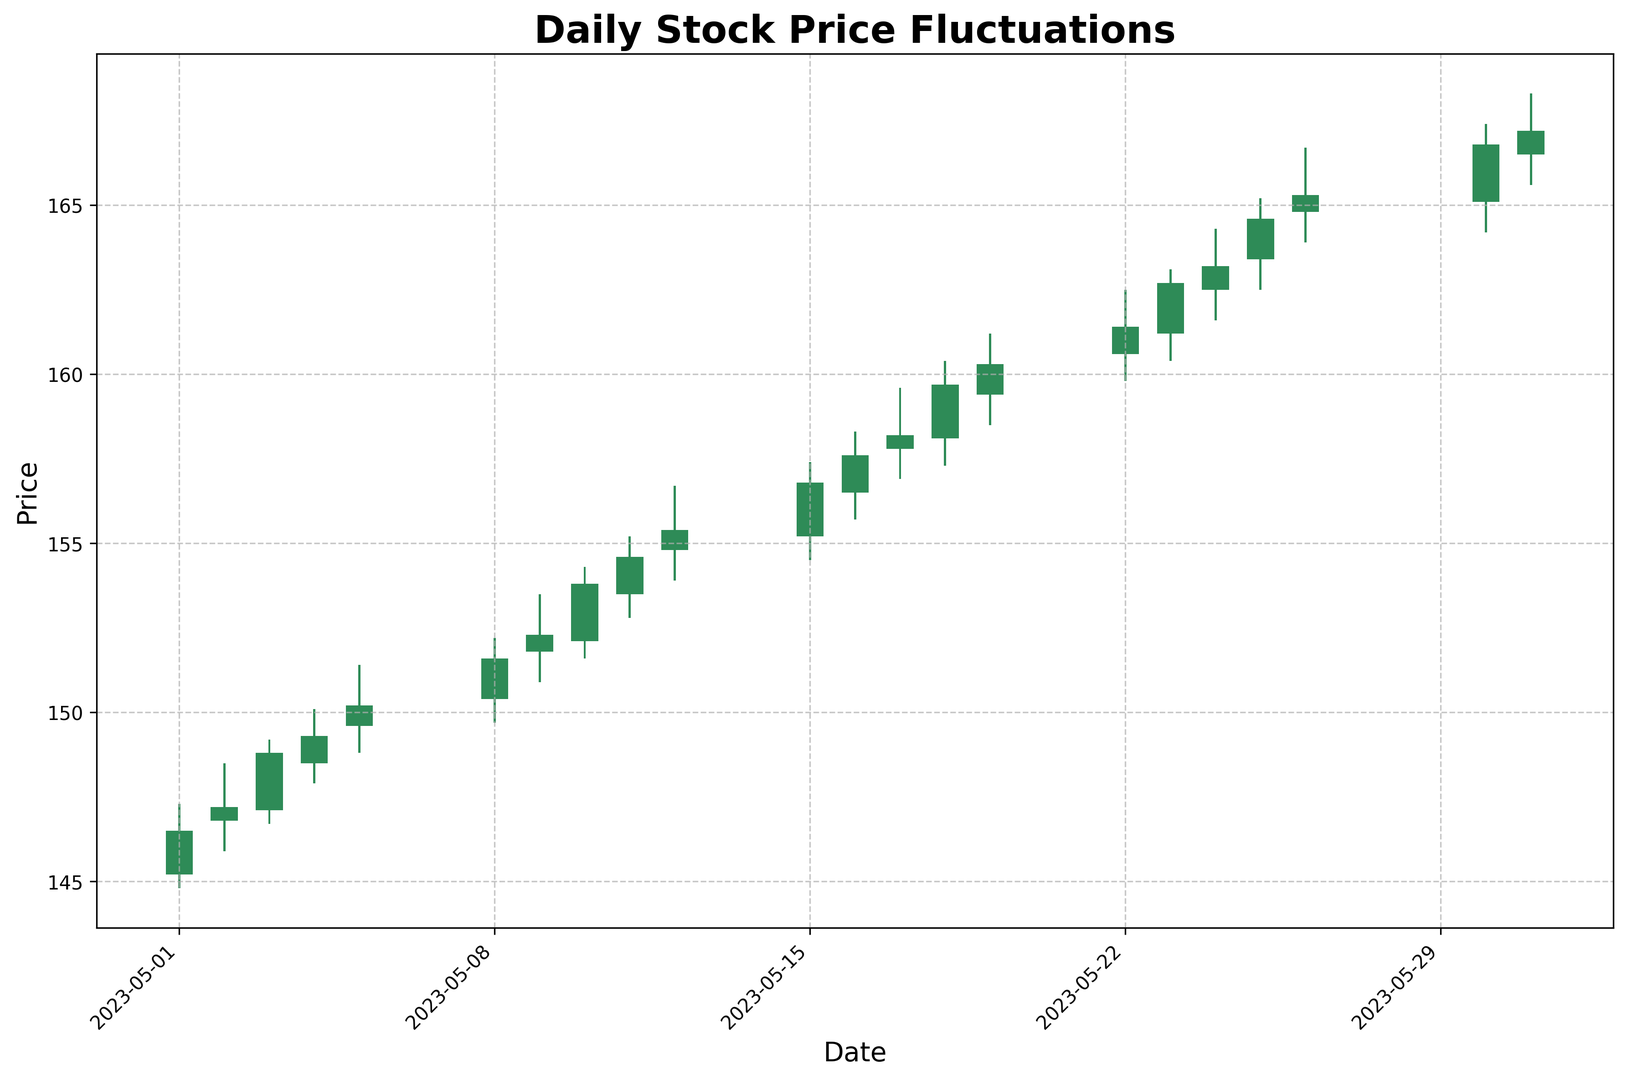Which day had the highest closing price? To determine the highest closing price, examine the closing price column for the peak value. The highest closing price is on 2023-05-31.
Answer: 2023-05-31 Which day had the largest difference between high and low prices? Calculate the difference between the high and low prices for each day and identify the maximum. The day with the largest difference is 2023-05-26, with a difference of 166.70 - 163.90 = 2.80.
Answer: 2023-05-26 Compare the opening prices on the first and last days of the month. Which is higher? Compare the opening price on 2023-05-01 (145.20) with that on 2023-05-31 (166.50). The latter is higher.
Answer: Last day is higher Which days had a higher closing price than the opening price? Identify the days where the closing price is greater than the opening price. The days are 2023-05-01, 2023-05-02, 2023-05-03, 2023-05-04, 2023-05-05, 2023-05-08, 2023-05-09, 2023-05-10, 2023-05-11, 2023-05-12, 2023-05-15, 2023-05-16, 2023-05-17, 2023-05-18, 2023-05-19, 2023-05-22, 2023-05-23, 2023-05-24, 2023-05-25, 2023-05-26, 2023-05-30, and 2023-05-31.
Answer: Every day Identify the day with the smallest range between high and low prices. Calculate the range between the high and low prices for each day and identify the smallest one. The smallest range is on 2023-05-01, with a range of 147.30 - 144.80 = 2.50.
Answer: 2023-05-01 What was the largest single-day price increase from open to close? Calculate the difference between the opening and closing prices for each day and identify the maximum positive difference. The largest increase is on 2023-05-26 with a change of 165.30 - 164.80 = 0.50.
Answer: 2023-05-26 Compare the highest prices reached on May 1st and May 15th. Which day had a higher peak? Compare the highest prices on 2023-05-01 (147.30) and 2023-05-15 (157.40). The latter is higher.
Answer: May 15th is higher On which days did the closing price end up lower than the opening price? Identify the days where the closing price is less than the opening price. There are no such days in this dataset.
Answer: None How many days had a closing price above 160.00? Count the number of days where the closing price exceeds 160.00. The days are from 2023-05-22 to 2023-05-31 inclusive, totaling 8 days.
Answer: 8 Which day showed the largest drop from its high to its closing price? Calculate the difference between the high and closing prices for each day and identify the maximum drop. The largest drop is on 2023-05-23, with a drop of 163.10 - 162.70 = 0.40.
Answer: 2023-05-23 